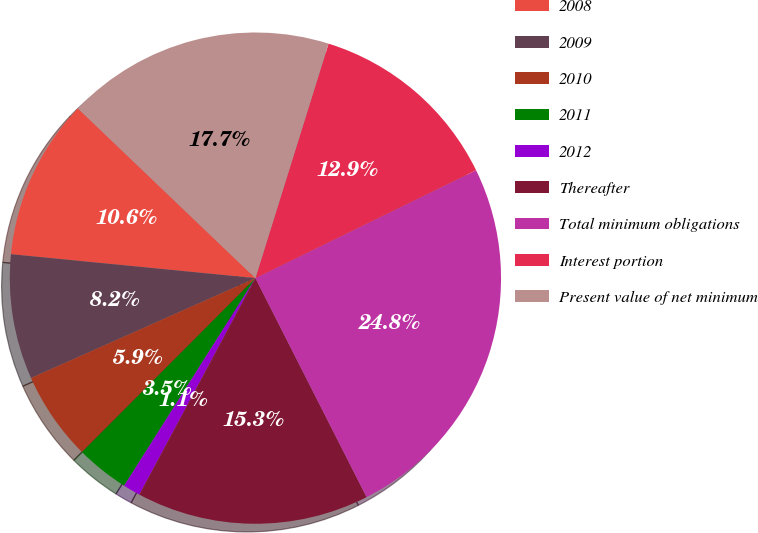Convert chart to OTSL. <chart><loc_0><loc_0><loc_500><loc_500><pie_chart><fcel>2008<fcel>2009<fcel>2010<fcel>2011<fcel>2012<fcel>Thereafter<fcel>Total minimum obligations<fcel>Interest portion<fcel>Present value of net minimum<nl><fcel>10.59%<fcel>8.22%<fcel>5.86%<fcel>3.5%<fcel>1.14%<fcel>15.31%<fcel>24.76%<fcel>12.95%<fcel>17.67%<nl></chart> 